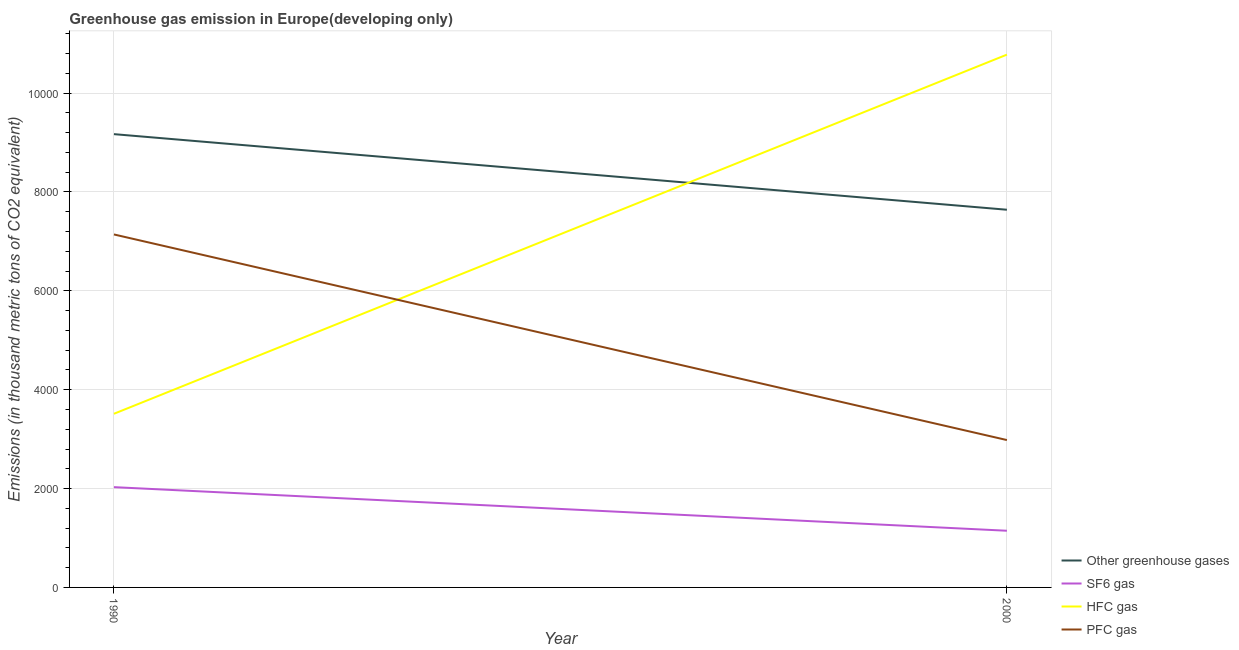How many different coloured lines are there?
Your answer should be compact. 4. Is the number of lines equal to the number of legend labels?
Keep it short and to the point. Yes. What is the emission of hfc gas in 2000?
Make the answer very short. 1.08e+04. Across all years, what is the maximum emission of sf6 gas?
Offer a very short reply. 2028.7. Across all years, what is the minimum emission of greenhouse gases?
Provide a succinct answer. 7640.7. In which year was the emission of greenhouse gases maximum?
Give a very brief answer. 1990. What is the total emission of sf6 gas in the graph?
Keep it short and to the point. 3175.3. What is the difference between the emission of sf6 gas in 1990 and that in 2000?
Your answer should be compact. 882.1. What is the difference between the emission of sf6 gas in 2000 and the emission of greenhouse gases in 1990?
Give a very brief answer. -8023.5. What is the average emission of pfc gas per year?
Your answer should be compact. 5061. In the year 1990, what is the difference between the emission of greenhouse gases and emission of pfc gas?
Your answer should be very brief. 2029.3. In how many years, is the emission of pfc gas greater than 7600 thousand metric tons?
Give a very brief answer. 0. What is the ratio of the emission of greenhouse gases in 1990 to that in 2000?
Your response must be concise. 1.2. Is it the case that in every year, the sum of the emission of greenhouse gases and emission of sf6 gas is greater than the sum of emission of hfc gas and emission of pfc gas?
Keep it short and to the point. No. Is it the case that in every year, the sum of the emission of greenhouse gases and emission of sf6 gas is greater than the emission of hfc gas?
Provide a succinct answer. No. Is the emission of hfc gas strictly less than the emission of sf6 gas over the years?
Your answer should be compact. No. How many lines are there?
Give a very brief answer. 4. What is the difference between two consecutive major ticks on the Y-axis?
Provide a short and direct response. 2000. Does the graph contain any zero values?
Make the answer very short. No. Where does the legend appear in the graph?
Provide a succinct answer. Bottom right. How many legend labels are there?
Give a very brief answer. 4. What is the title of the graph?
Keep it short and to the point. Greenhouse gas emission in Europe(developing only). Does "Management rating" appear as one of the legend labels in the graph?
Your response must be concise. No. What is the label or title of the X-axis?
Give a very brief answer. Year. What is the label or title of the Y-axis?
Offer a very short reply. Emissions (in thousand metric tons of CO2 equivalent). What is the Emissions (in thousand metric tons of CO2 equivalent) in Other greenhouse gases in 1990?
Your answer should be very brief. 9170.1. What is the Emissions (in thousand metric tons of CO2 equivalent) in SF6 gas in 1990?
Provide a short and direct response. 2028.7. What is the Emissions (in thousand metric tons of CO2 equivalent) of HFC gas in 1990?
Make the answer very short. 3512.9. What is the Emissions (in thousand metric tons of CO2 equivalent) of PFC gas in 1990?
Ensure brevity in your answer.  7140.8. What is the Emissions (in thousand metric tons of CO2 equivalent) in Other greenhouse gases in 2000?
Ensure brevity in your answer.  7640.7. What is the Emissions (in thousand metric tons of CO2 equivalent) of SF6 gas in 2000?
Provide a short and direct response. 1146.6. What is the Emissions (in thousand metric tons of CO2 equivalent) in HFC gas in 2000?
Offer a very short reply. 1.08e+04. What is the Emissions (in thousand metric tons of CO2 equivalent) in PFC gas in 2000?
Your answer should be compact. 2981.2. Across all years, what is the maximum Emissions (in thousand metric tons of CO2 equivalent) of Other greenhouse gases?
Your response must be concise. 9170.1. Across all years, what is the maximum Emissions (in thousand metric tons of CO2 equivalent) in SF6 gas?
Offer a very short reply. 2028.7. Across all years, what is the maximum Emissions (in thousand metric tons of CO2 equivalent) in HFC gas?
Offer a very short reply. 1.08e+04. Across all years, what is the maximum Emissions (in thousand metric tons of CO2 equivalent) of PFC gas?
Provide a succinct answer. 7140.8. Across all years, what is the minimum Emissions (in thousand metric tons of CO2 equivalent) of Other greenhouse gases?
Provide a short and direct response. 7640.7. Across all years, what is the minimum Emissions (in thousand metric tons of CO2 equivalent) in SF6 gas?
Offer a terse response. 1146.6. Across all years, what is the minimum Emissions (in thousand metric tons of CO2 equivalent) of HFC gas?
Ensure brevity in your answer.  3512.9. Across all years, what is the minimum Emissions (in thousand metric tons of CO2 equivalent) of PFC gas?
Ensure brevity in your answer.  2981.2. What is the total Emissions (in thousand metric tons of CO2 equivalent) of Other greenhouse gases in the graph?
Provide a succinct answer. 1.68e+04. What is the total Emissions (in thousand metric tons of CO2 equivalent) in SF6 gas in the graph?
Your response must be concise. 3175.3. What is the total Emissions (in thousand metric tons of CO2 equivalent) in HFC gas in the graph?
Offer a very short reply. 1.43e+04. What is the total Emissions (in thousand metric tons of CO2 equivalent) in PFC gas in the graph?
Your response must be concise. 1.01e+04. What is the difference between the Emissions (in thousand metric tons of CO2 equivalent) of Other greenhouse gases in 1990 and that in 2000?
Provide a short and direct response. 1529.4. What is the difference between the Emissions (in thousand metric tons of CO2 equivalent) of SF6 gas in 1990 and that in 2000?
Give a very brief answer. 882.1. What is the difference between the Emissions (in thousand metric tons of CO2 equivalent) in HFC gas in 1990 and that in 2000?
Your answer should be compact. -7265.83. What is the difference between the Emissions (in thousand metric tons of CO2 equivalent) in PFC gas in 1990 and that in 2000?
Your answer should be compact. 4159.6. What is the difference between the Emissions (in thousand metric tons of CO2 equivalent) in Other greenhouse gases in 1990 and the Emissions (in thousand metric tons of CO2 equivalent) in SF6 gas in 2000?
Ensure brevity in your answer.  8023.5. What is the difference between the Emissions (in thousand metric tons of CO2 equivalent) in Other greenhouse gases in 1990 and the Emissions (in thousand metric tons of CO2 equivalent) in HFC gas in 2000?
Your answer should be very brief. -1608.63. What is the difference between the Emissions (in thousand metric tons of CO2 equivalent) of Other greenhouse gases in 1990 and the Emissions (in thousand metric tons of CO2 equivalent) of PFC gas in 2000?
Your answer should be compact. 6188.9. What is the difference between the Emissions (in thousand metric tons of CO2 equivalent) of SF6 gas in 1990 and the Emissions (in thousand metric tons of CO2 equivalent) of HFC gas in 2000?
Make the answer very short. -8750.03. What is the difference between the Emissions (in thousand metric tons of CO2 equivalent) of SF6 gas in 1990 and the Emissions (in thousand metric tons of CO2 equivalent) of PFC gas in 2000?
Your answer should be compact. -952.5. What is the difference between the Emissions (in thousand metric tons of CO2 equivalent) of HFC gas in 1990 and the Emissions (in thousand metric tons of CO2 equivalent) of PFC gas in 2000?
Your answer should be very brief. 531.7. What is the average Emissions (in thousand metric tons of CO2 equivalent) of Other greenhouse gases per year?
Make the answer very short. 8405.4. What is the average Emissions (in thousand metric tons of CO2 equivalent) of SF6 gas per year?
Ensure brevity in your answer.  1587.65. What is the average Emissions (in thousand metric tons of CO2 equivalent) in HFC gas per year?
Ensure brevity in your answer.  7145.81. What is the average Emissions (in thousand metric tons of CO2 equivalent) in PFC gas per year?
Ensure brevity in your answer.  5061. In the year 1990, what is the difference between the Emissions (in thousand metric tons of CO2 equivalent) of Other greenhouse gases and Emissions (in thousand metric tons of CO2 equivalent) of SF6 gas?
Give a very brief answer. 7141.4. In the year 1990, what is the difference between the Emissions (in thousand metric tons of CO2 equivalent) in Other greenhouse gases and Emissions (in thousand metric tons of CO2 equivalent) in HFC gas?
Provide a succinct answer. 5657.2. In the year 1990, what is the difference between the Emissions (in thousand metric tons of CO2 equivalent) in Other greenhouse gases and Emissions (in thousand metric tons of CO2 equivalent) in PFC gas?
Your answer should be compact. 2029.3. In the year 1990, what is the difference between the Emissions (in thousand metric tons of CO2 equivalent) of SF6 gas and Emissions (in thousand metric tons of CO2 equivalent) of HFC gas?
Offer a terse response. -1484.2. In the year 1990, what is the difference between the Emissions (in thousand metric tons of CO2 equivalent) of SF6 gas and Emissions (in thousand metric tons of CO2 equivalent) of PFC gas?
Your answer should be very brief. -5112.1. In the year 1990, what is the difference between the Emissions (in thousand metric tons of CO2 equivalent) of HFC gas and Emissions (in thousand metric tons of CO2 equivalent) of PFC gas?
Your answer should be very brief. -3627.9. In the year 2000, what is the difference between the Emissions (in thousand metric tons of CO2 equivalent) of Other greenhouse gases and Emissions (in thousand metric tons of CO2 equivalent) of SF6 gas?
Provide a succinct answer. 6494.1. In the year 2000, what is the difference between the Emissions (in thousand metric tons of CO2 equivalent) of Other greenhouse gases and Emissions (in thousand metric tons of CO2 equivalent) of HFC gas?
Provide a short and direct response. -3138.03. In the year 2000, what is the difference between the Emissions (in thousand metric tons of CO2 equivalent) of Other greenhouse gases and Emissions (in thousand metric tons of CO2 equivalent) of PFC gas?
Keep it short and to the point. 4659.5. In the year 2000, what is the difference between the Emissions (in thousand metric tons of CO2 equivalent) of SF6 gas and Emissions (in thousand metric tons of CO2 equivalent) of HFC gas?
Your answer should be compact. -9632.13. In the year 2000, what is the difference between the Emissions (in thousand metric tons of CO2 equivalent) of SF6 gas and Emissions (in thousand metric tons of CO2 equivalent) of PFC gas?
Make the answer very short. -1834.6. In the year 2000, what is the difference between the Emissions (in thousand metric tons of CO2 equivalent) in HFC gas and Emissions (in thousand metric tons of CO2 equivalent) in PFC gas?
Offer a very short reply. 7797.53. What is the ratio of the Emissions (in thousand metric tons of CO2 equivalent) in Other greenhouse gases in 1990 to that in 2000?
Give a very brief answer. 1.2. What is the ratio of the Emissions (in thousand metric tons of CO2 equivalent) in SF6 gas in 1990 to that in 2000?
Provide a succinct answer. 1.77. What is the ratio of the Emissions (in thousand metric tons of CO2 equivalent) of HFC gas in 1990 to that in 2000?
Offer a very short reply. 0.33. What is the ratio of the Emissions (in thousand metric tons of CO2 equivalent) in PFC gas in 1990 to that in 2000?
Offer a terse response. 2.4. What is the difference between the highest and the second highest Emissions (in thousand metric tons of CO2 equivalent) of Other greenhouse gases?
Your answer should be very brief. 1529.4. What is the difference between the highest and the second highest Emissions (in thousand metric tons of CO2 equivalent) of SF6 gas?
Provide a succinct answer. 882.1. What is the difference between the highest and the second highest Emissions (in thousand metric tons of CO2 equivalent) of HFC gas?
Make the answer very short. 7265.83. What is the difference between the highest and the second highest Emissions (in thousand metric tons of CO2 equivalent) in PFC gas?
Your answer should be very brief. 4159.6. What is the difference between the highest and the lowest Emissions (in thousand metric tons of CO2 equivalent) in Other greenhouse gases?
Your answer should be compact. 1529.4. What is the difference between the highest and the lowest Emissions (in thousand metric tons of CO2 equivalent) of SF6 gas?
Your answer should be compact. 882.1. What is the difference between the highest and the lowest Emissions (in thousand metric tons of CO2 equivalent) in HFC gas?
Your answer should be compact. 7265.83. What is the difference between the highest and the lowest Emissions (in thousand metric tons of CO2 equivalent) in PFC gas?
Provide a short and direct response. 4159.6. 